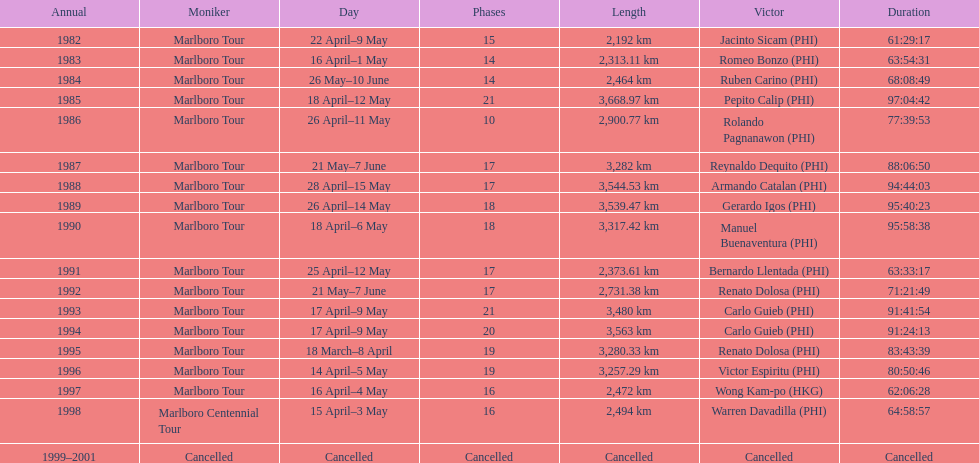How many marlboro tours did carlo guieb win? 2. 